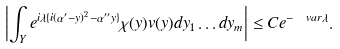Convert formula to latex. <formula><loc_0><loc_0><loc_500><loc_500>\left | \int _ { Y } e ^ { i \lambda \{ i ( \alpha ^ { \prime } - y ) ^ { 2 } - \alpha ^ { \prime \prime } y \} } \chi ( y ) v ( y ) d y _ { 1 } \dots d y _ { m } \right | \leq C e ^ { - \ v a r \lambda } .</formula> 